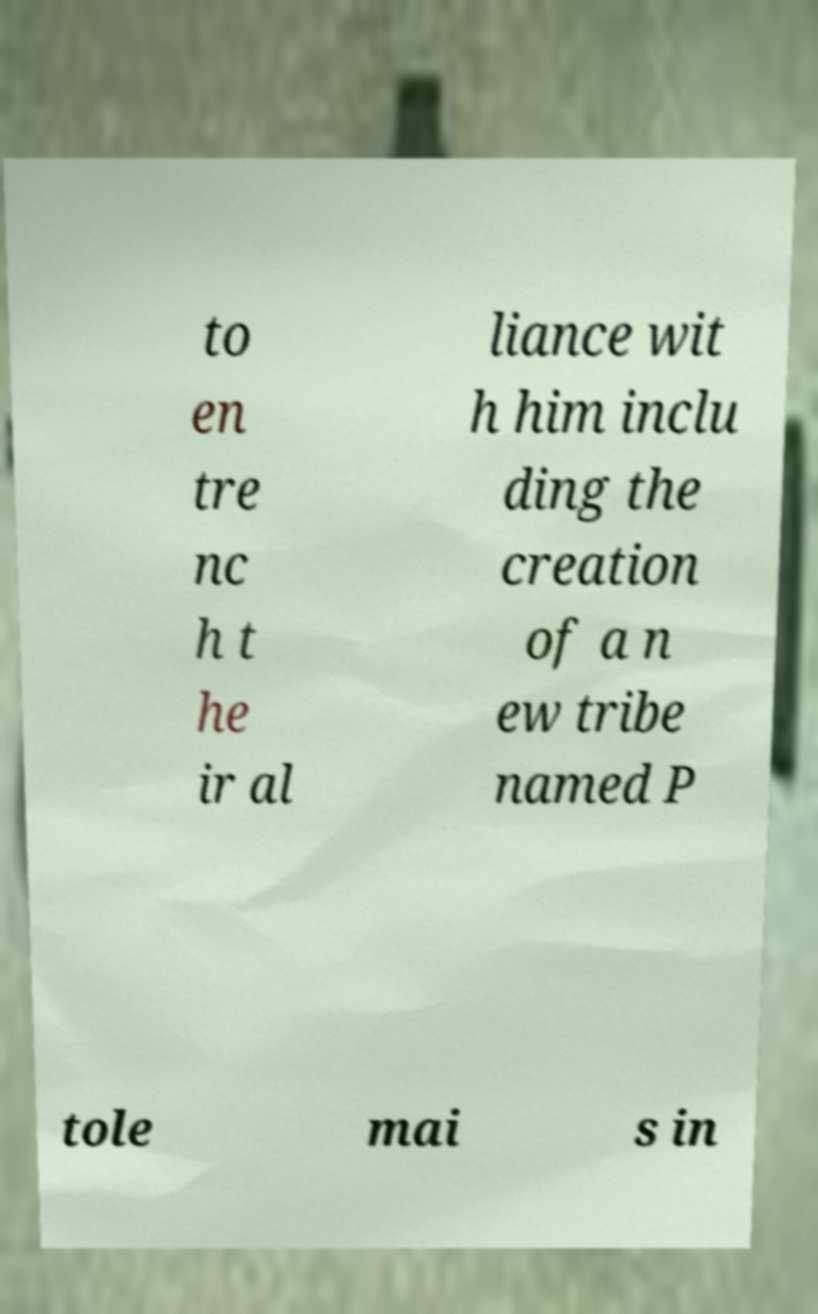There's text embedded in this image that I need extracted. Can you transcribe it verbatim? to en tre nc h t he ir al liance wit h him inclu ding the creation of a n ew tribe named P tole mai s in 